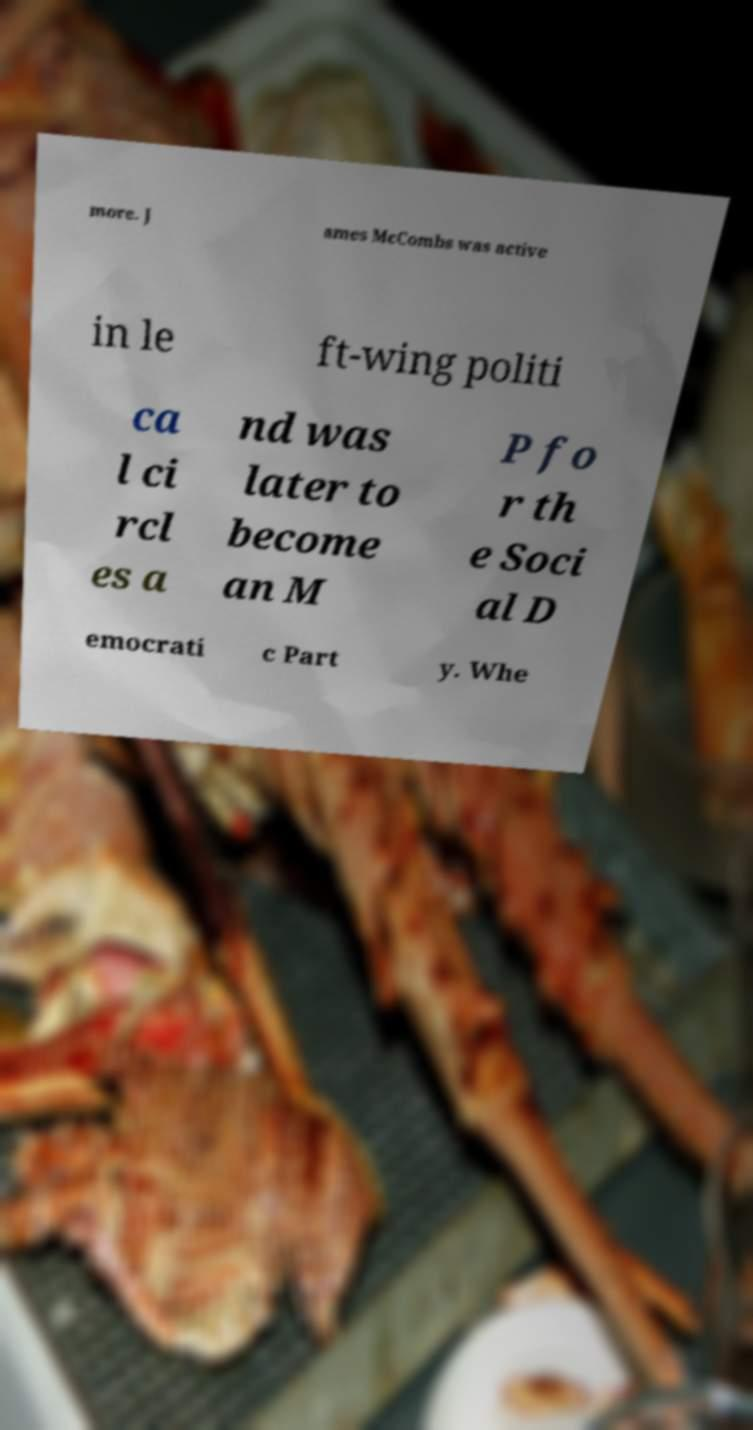Please identify and transcribe the text found in this image. more. J ames McCombs was active in le ft-wing politi ca l ci rcl es a nd was later to become an M P fo r th e Soci al D emocrati c Part y. Whe 